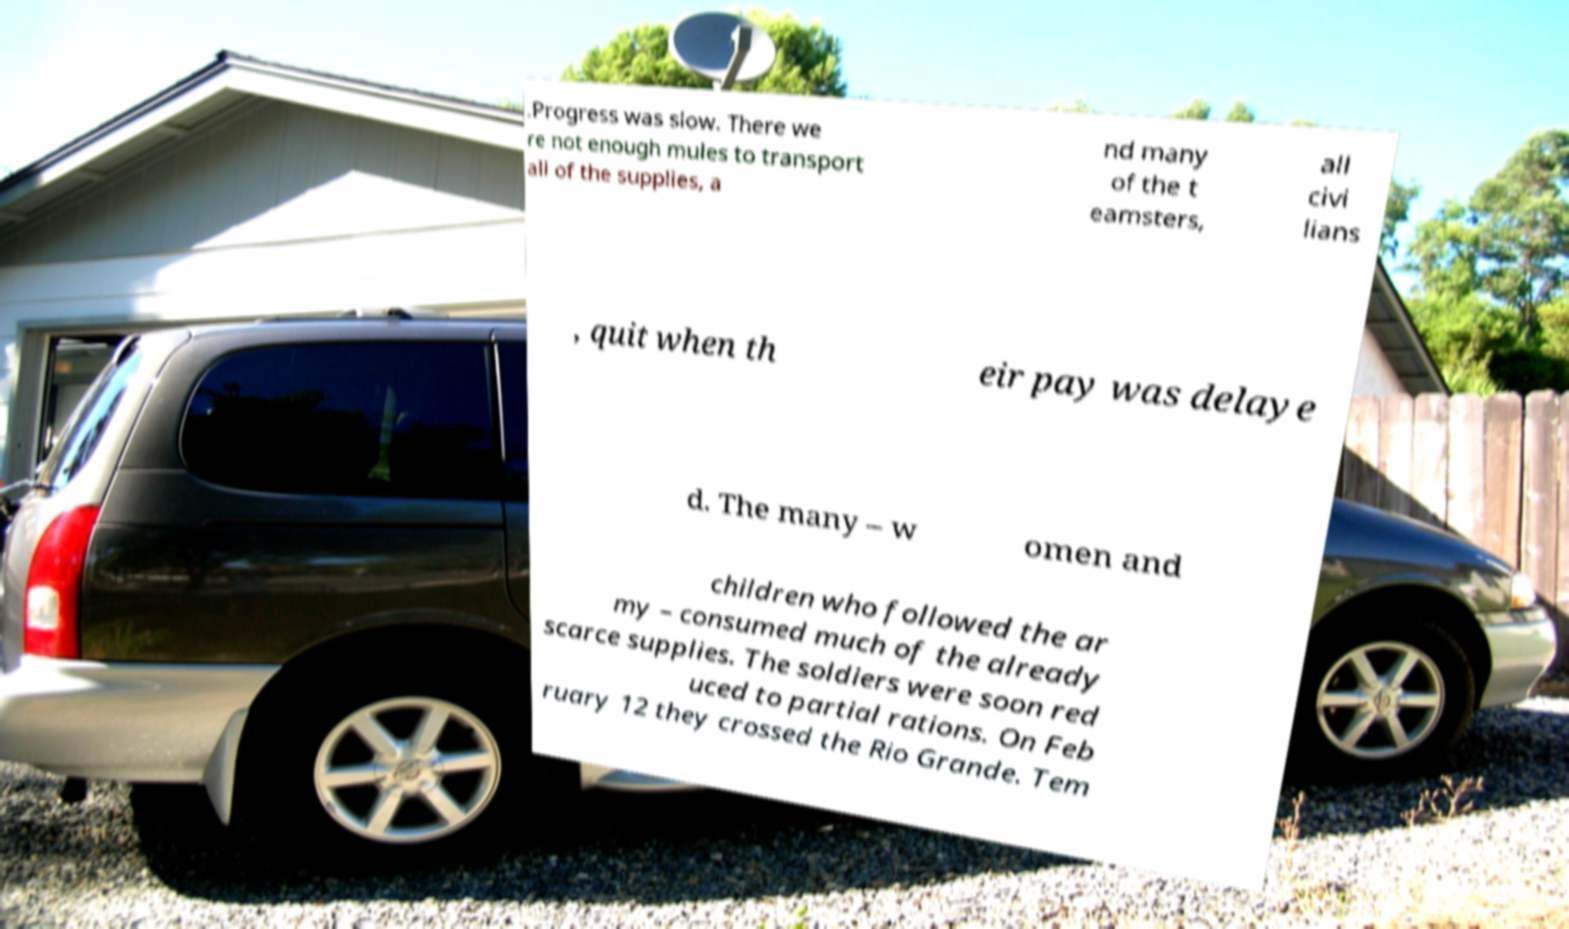There's text embedded in this image that I need extracted. Can you transcribe it verbatim? .Progress was slow. There we re not enough mules to transport all of the supplies, a nd many of the t eamsters, all civi lians , quit when th eir pay was delaye d. The many – w omen and children who followed the ar my – consumed much of the already scarce supplies. The soldiers were soon red uced to partial rations. On Feb ruary 12 they crossed the Rio Grande. Tem 